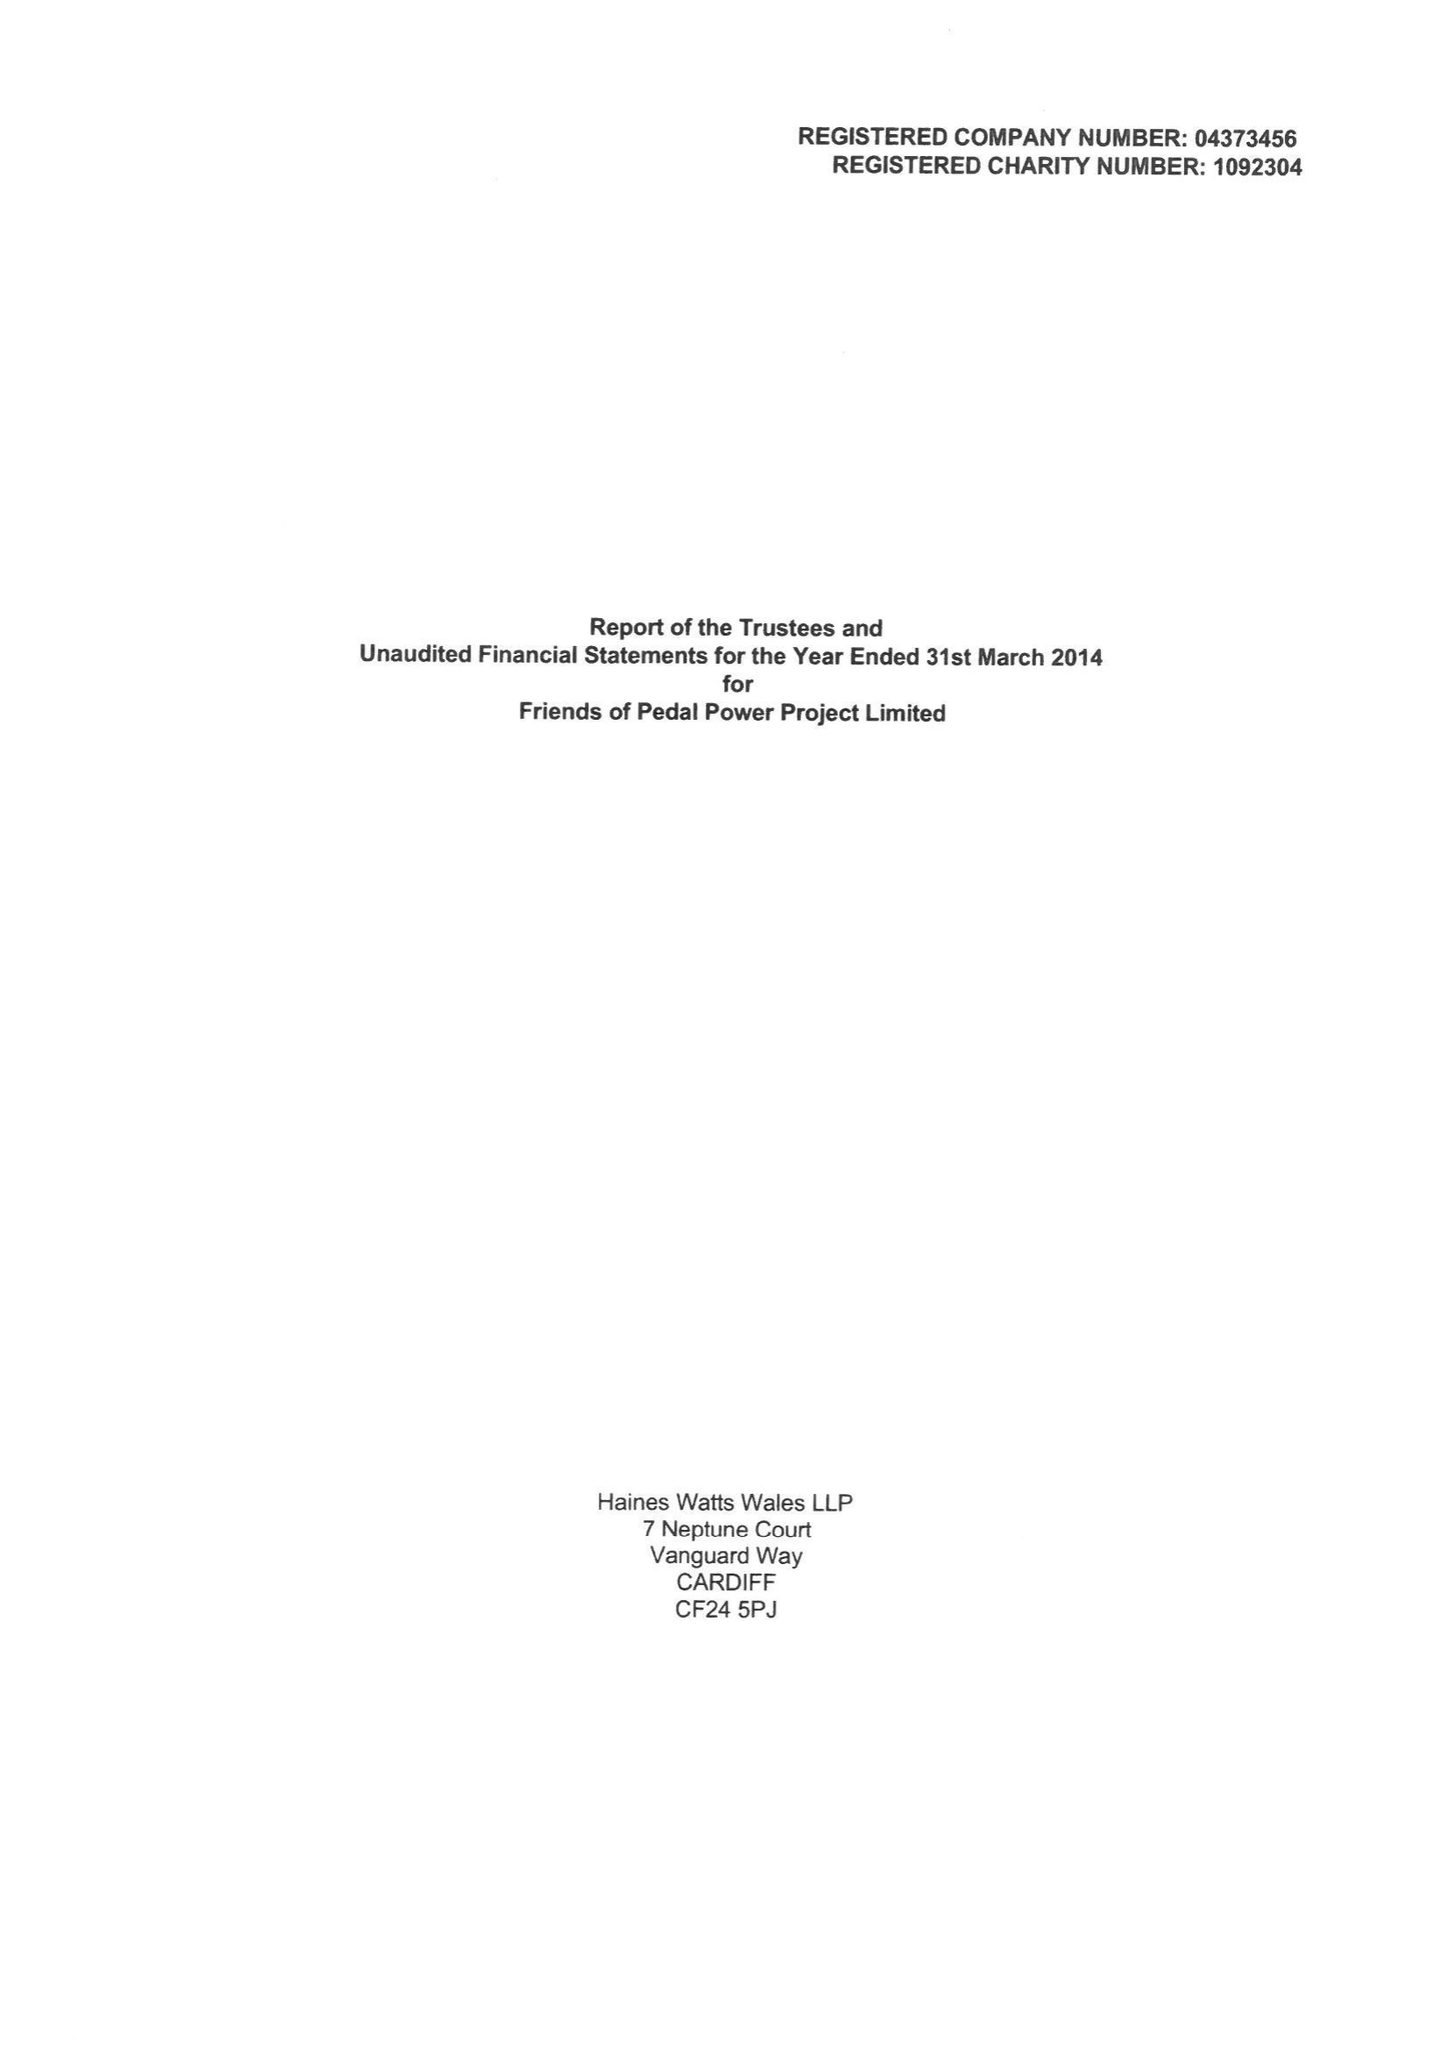What is the value for the charity_number?
Answer the question using a single word or phrase. 1092304 